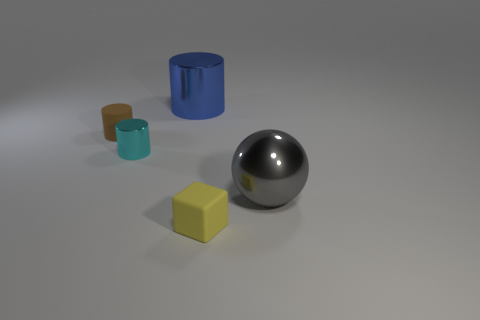What material is the cylinder in front of the matte thing behind the large object on the right side of the small yellow matte block made of? The cylinder in question appears to be made of a material with a smooth, reflective surface, suggesting it is likely made of metal. Metals are often used in objects like these, which are depicted in 3D renderings, for their sleek appearance and reflective properties that can be effectively rendered with computer graphics. 